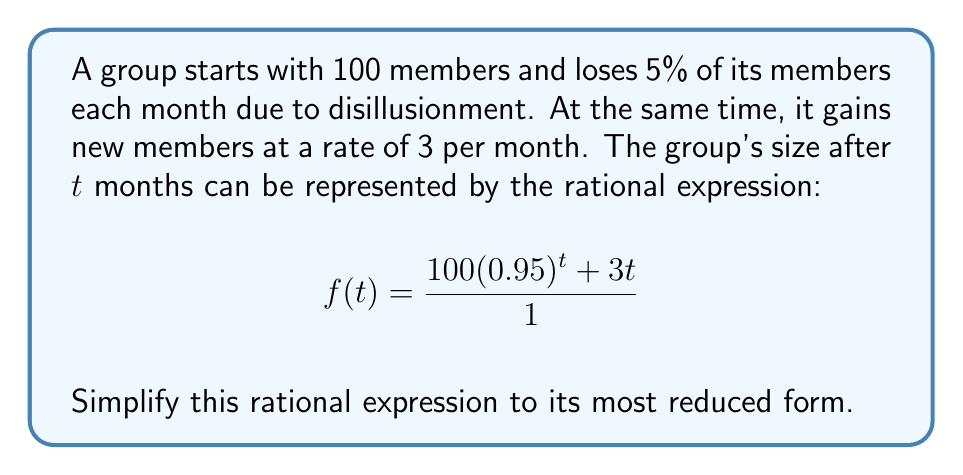Can you answer this question? Let's simplify this rational expression step by step:

1) First, we notice that the denominator is 1, so we can focus on simplifying the numerator.

2) The numerator consists of two terms: $100(0.95)^t$ and $3t$

3) These terms cannot be combined further as they have different bases (0.95 and t).

4) The greatest common factor (GCF) of these terms is 1, so no further factoring is possible.

5) Since the denominator is 1 and there are no common factors between the numerator and denominator, this expression is already in its simplest form.

6) Therefore, $f(t) = 100(0.95)^t + 3t$ is the simplified rational expression.
Answer: $f(t) = 100(0.95)^t + 3t$ 